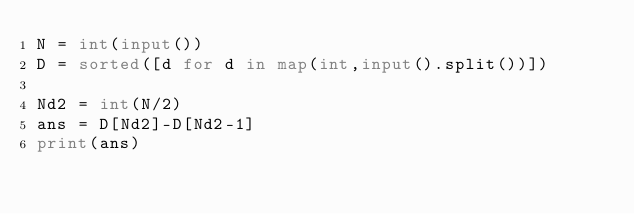Convert code to text. <code><loc_0><loc_0><loc_500><loc_500><_Python_>N = int(input())
D = sorted([d for d in map(int,input().split())])

Nd2 = int(N/2)
ans = D[Nd2]-D[Nd2-1]
print(ans)</code> 